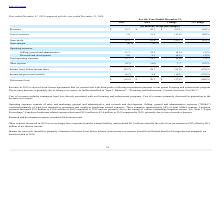According to Finjan Holding's financial document, Where is revenue in 2019 derived from? license agreements that we entered into with third-parties following negotiations pursuant to our patent licensing and enforcement program. The document states: "Revenue in 2019 is derived from license agreements that we entered into with third-parties following negotiations pursuant to our patent licensing and..." Also, How much is litigation expenses in 2019 and what was the increase in litigation expenses between 2018 and 2019? The document shows two values: $19.4 million and $3.0 million. From the document: "nse. Litigation expenses increased $3.0 million to $19.4 million in 2019 compared to 2018 and are primarily due to the timing of various outstanding l..." Also, What does cost of revenues comprise? contingent legal fees directly associated with our licensing and enforcement programs. The document states: "Cost of revenues includes contingent legal fees directly associated with our licensing and enforcement programs. Cost of revenues primarily decreased ..." Also, can you calculate: What is the percentage change in revenue between 2018 and 2019? To answer this question, I need to perform calculations using the financial data. The calculation is: (13.2-82.3)/82.3 , which equals -83.96 (percentage). This is based on the information: "Revenues $ 13.2 $ 82.3 $ (69.1) (84) % Revenues $ 13.2 $ 82.3 $ (69.1) (84) %..." The key data points involved are: 13.2, 82.3. Also, can you calculate: What is the value of litigation expenses in 2019 as a percentage of the 2019 gross profit? Based on the calculation: 19.4/11.3 , the result is 171.68 (percentage). This is based on the information: "Gross profit 11.3 67.0 (55.7) (83) % e. Litigation expenses increased $3.0 million to $19.4 million in 2019 compared to 2018 and are primarily due to the timing of various outstanding litigat..." The key data points involved are: 11.3, 19.4. Also, can you calculate: What is the value of employee headcount related expenses as a percentage of the cost of revenues in 2019? Based on the calculation: 3.6/1.9 , the result is 189.47 (percentage). This is based on the information: "Cost of revenues 1.9 15.3 (13.4) (88) % count related expenses decreased $2.0 million to $3.6 million in 2019 compared to 2018, primarily due to lower incentive bonuses...." The key data points involved are: 1.9, 3.6. 